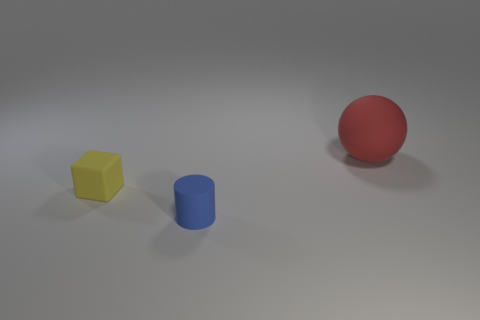Are there any other things of the same color as the cylinder?
Provide a short and direct response. No. The tiny matte object that is right of the tiny rubber object that is behind the blue object is what shape?
Ensure brevity in your answer.  Cylinder. What is the size of the thing that is behind the small object behind the blue matte cylinder in front of the yellow block?
Provide a succinct answer. Large. Is the blue cylinder the same size as the red object?
Offer a very short reply. No. What number of things are small matte cubes or red matte balls?
Provide a succinct answer. 2. There is a thing behind the small rubber thing that is on the left side of the rubber cylinder; how big is it?
Offer a terse response. Large. What is the size of the red matte object?
Make the answer very short. Large. There is a matte object that is both behind the blue cylinder and in front of the big red rubber object; what is its shape?
Your answer should be compact. Cube. What number of objects are either objects in front of the red rubber object or objects that are to the right of the cylinder?
Give a very brief answer. 3. What shape is the small yellow object?
Ensure brevity in your answer.  Cube. 